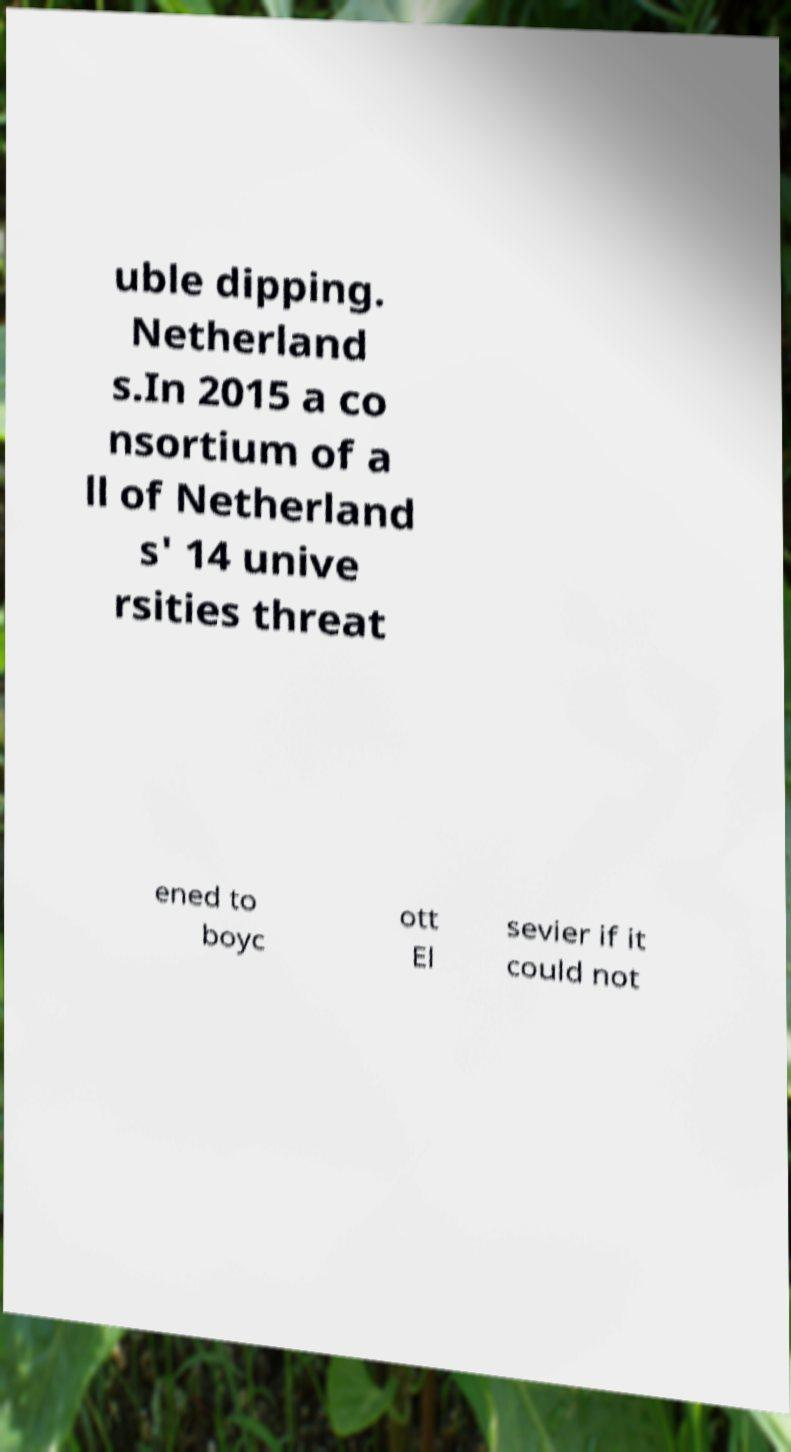Please read and relay the text visible in this image. What does it say? uble dipping. Netherland s.In 2015 a co nsortium of a ll of Netherland s' 14 unive rsities threat ened to boyc ott El sevier if it could not 